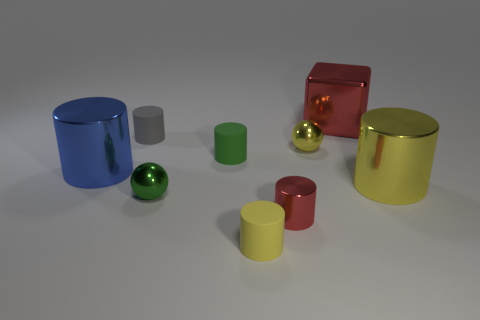What color is the cube?
Your answer should be very brief. Red. Do the cube and the metallic cylinder in front of the yellow metallic cylinder have the same color?
Provide a succinct answer. Yes. There is a tiny yellow matte cylinder; are there any metal cubes in front of it?
Offer a terse response. No. There is a green object that is behind the big blue metal cylinder; is there a small red shiny cylinder that is behind it?
Offer a very short reply. No. Is the number of tiny cylinders that are left of the blue cylinder the same as the number of yellow things behind the small green metal object?
Offer a very short reply. No. The small cylinder that is made of the same material as the cube is what color?
Your answer should be compact. Red. Is there a large purple cube made of the same material as the blue cylinder?
Your answer should be very brief. No. What number of objects are large shiny blocks or big matte objects?
Your response must be concise. 1. Does the green ball have the same material as the tiny ball that is behind the yellow metal cylinder?
Your answer should be very brief. Yes. There is a red thing that is in front of the red metal block; how big is it?
Make the answer very short. Small. 